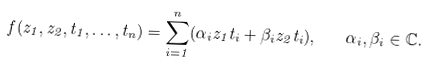Convert formula to latex. <formula><loc_0><loc_0><loc_500><loc_500>f ( z _ { 1 } , z _ { 2 } , t _ { 1 } , \dots , t _ { n } ) = \sum _ { i = 1 } ^ { n } ( \alpha _ { i } z _ { 1 } t _ { i } + \beta _ { i } z _ { 2 } t _ { i } ) , \quad \alpha _ { i } , \beta _ { i } \in { \mathbb { C } } .</formula> 